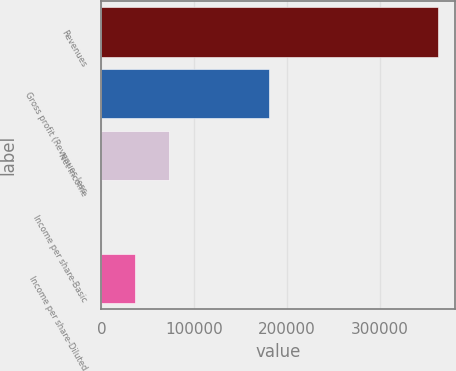Convert chart. <chart><loc_0><loc_0><loc_500><loc_500><bar_chart><fcel>Revenues<fcel>Gross profit (Revenues less<fcel>Net income<fcel>Income per share-Basic<fcel>Income per share-Diluted<nl><fcel>362500<fcel>180265<fcel>72500.1<fcel>0.15<fcel>36250.1<nl></chart> 